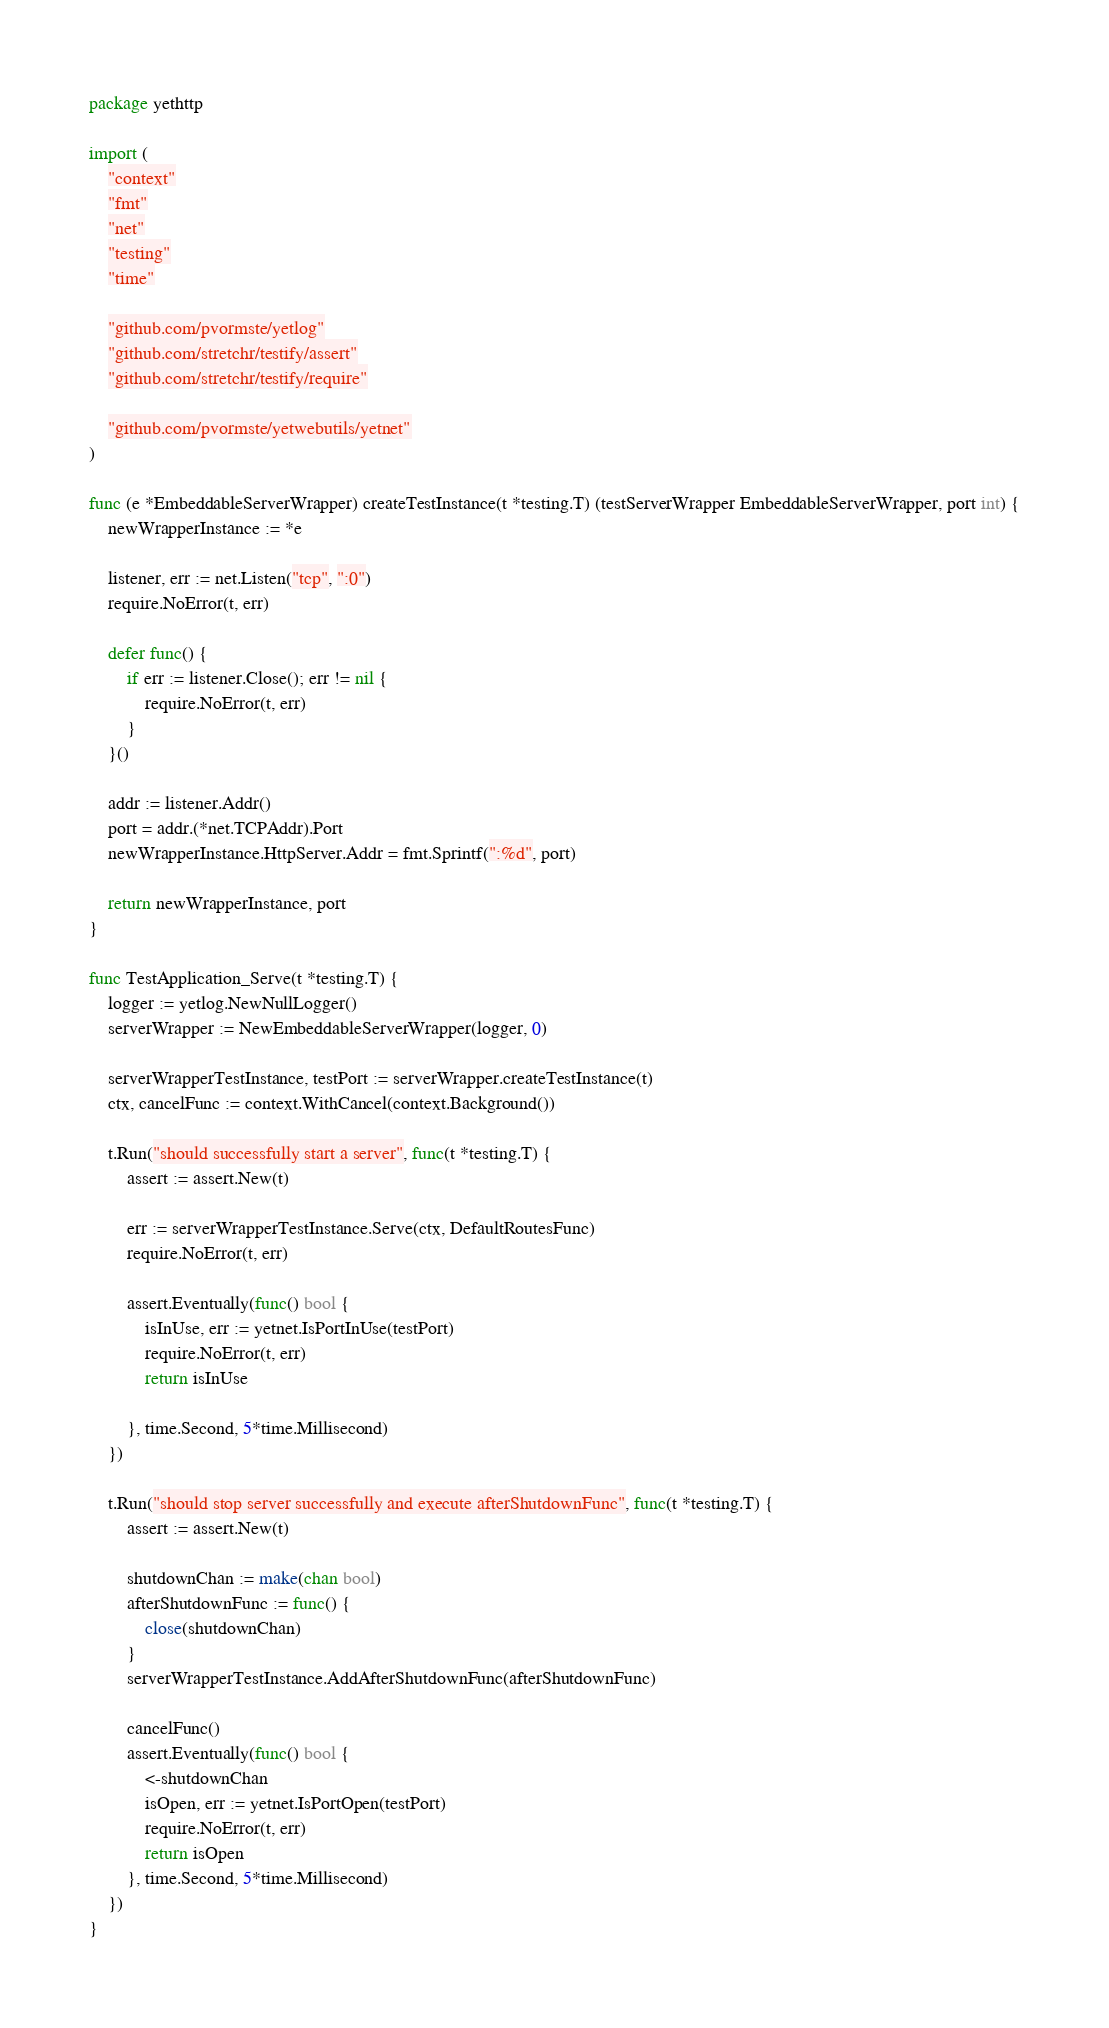Convert code to text. <code><loc_0><loc_0><loc_500><loc_500><_Go_>package yethttp

import (
	"context"
	"fmt"
	"net"
	"testing"
	"time"

	"github.com/pvormste/yetlog"
	"github.com/stretchr/testify/assert"
	"github.com/stretchr/testify/require"

	"github.com/pvormste/yetwebutils/yetnet"
)

func (e *EmbeddableServerWrapper) createTestInstance(t *testing.T) (testServerWrapper EmbeddableServerWrapper, port int) {
	newWrapperInstance := *e

	listener, err := net.Listen("tcp", ":0")
	require.NoError(t, err)

	defer func() {
		if err := listener.Close(); err != nil {
			require.NoError(t, err)
		}
	}()

	addr := listener.Addr()
	port = addr.(*net.TCPAddr).Port
	newWrapperInstance.HttpServer.Addr = fmt.Sprintf(":%d", port)

	return newWrapperInstance, port
}

func TestApplication_Serve(t *testing.T) {
	logger := yetlog.NewNullLogger()
	serverWrapper := NewEmbeddableServerWrapper(logger, 0)

	serverWrapperTestInstance, testPort := serverWrapper.createTestInstance(t)
	ctx, cancelFunc := context.WithCancel(context.Background())

	t.Run("should successfully start a server", func(t *testing.T) {
		assert := assert.New(t)

		err := serverWrapperTestInstance.Serve(ctx, DefaultRoutesFunc)
		require.NoError(t, err)

		assert.Eventually(func() bool {
			isInUse, err := yetnet.IsPortInUse(testPort)
			require.NoError(t, err)
			return isInUse

		}, time.Second, 5*time.Millisecond)
	})

	t.Run("should stop server successfully and execute afterShutdownFunc", func(t *testing.T) {
		assert := assert.New(t)

		shutdownChan := make(chan bool)
		afterShutdownFunc := func() {
			close(shutdownChan)
		}
		serverWrapperTestInstance.AddAfterShutdownFunc(afterShutdownFunc)

		cancelFunc()
		assert.Eventually(func() bool {
			<-shutdownChan
			isOpen, err := yetnet.IsPortOpen(testPort)
			require.NoError(t, err)
			return isOpen
		}, time.Second, 5*time.Millisecond)
	})
}
</code> 